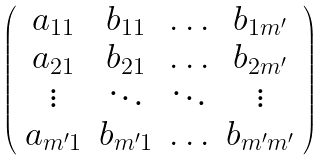Convert formula to latex. <formula><loc_0><loc_0><loc_500><loc_500>\left ( \begin{array} { c c c c } a _ { 1 1 } & b _ { 1 1 } & \hdots & b _ { 1 m ^ { \prime } } \\ a _ { 2 1 } & b _ { 2 1 } & \hdots & b _ { 2 m ^ { \prime } } \\ \vdots & \ddots & \ddots & \vdots \\ a _ { m ^ { \prime } 1 } & b _ { m ^ { \prime } 1 } & \hdots & b _ { m ^ { \prime } m ^ { \prime } } \end{array} \right )</formula> 